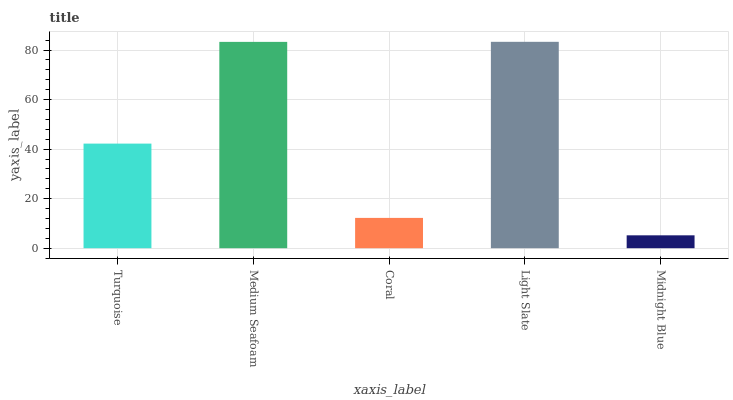Is Midnight Blue the minimum?
Answer yes or no. Yes. Is Light Slate the maximum?
Answer yes or no. Yes. Is Medium Seafoam the minimum?
Answer yes or no. No. Is Medium Seafoam the maximum?
Answer yes or no. No. Is Medium Seafoam greater than Turquoise?
Answer yes or no. Yes. Is Turquoise less than Medium Seafoam?
Answer yes or no. Yes. Is Turquoise greater than Medium Seafoam?
Answer yes or no. No. Is Medium Seafoam less than Turquoise?
Answer yes or no. No. Is Turquoise the high median?
Answer yes or no. Yes. Is Turquoise the low median?
Answer yes or no. Yes. Is Light Slate the high median?
Answer yes or no. No. Is Coral the low median?
Answer yes or no. No. 